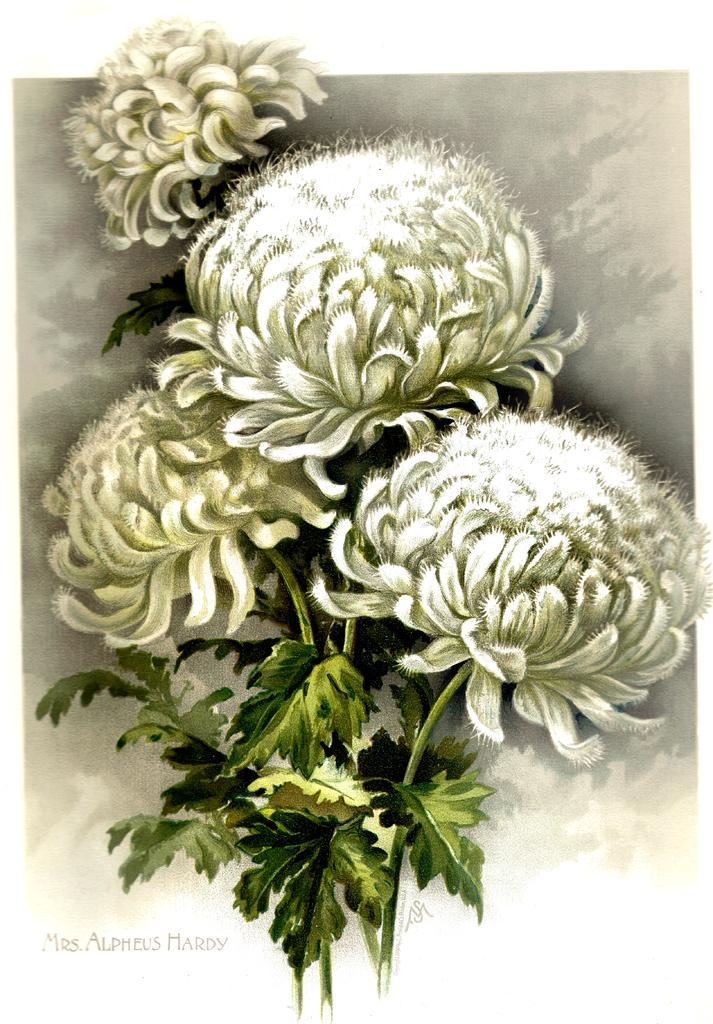What type of artwork is depicted in the image? The image appears to be a painting. What is the main subject of the painting? There is a bunch of flowers with leaves in the image. Are there any words or letters in the painting? Yes, there are letters in the image. What is the color of the background in the painting? The background of the image has a grayish color. How many mittens can be seen on the feet of the person in the painting? There is no person or feet visible in the painting; it features a bunch of flowers with leaves and letters. 